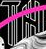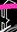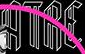Read the text content from these images in order, separated by a semicolon. TH; #; ATRE 